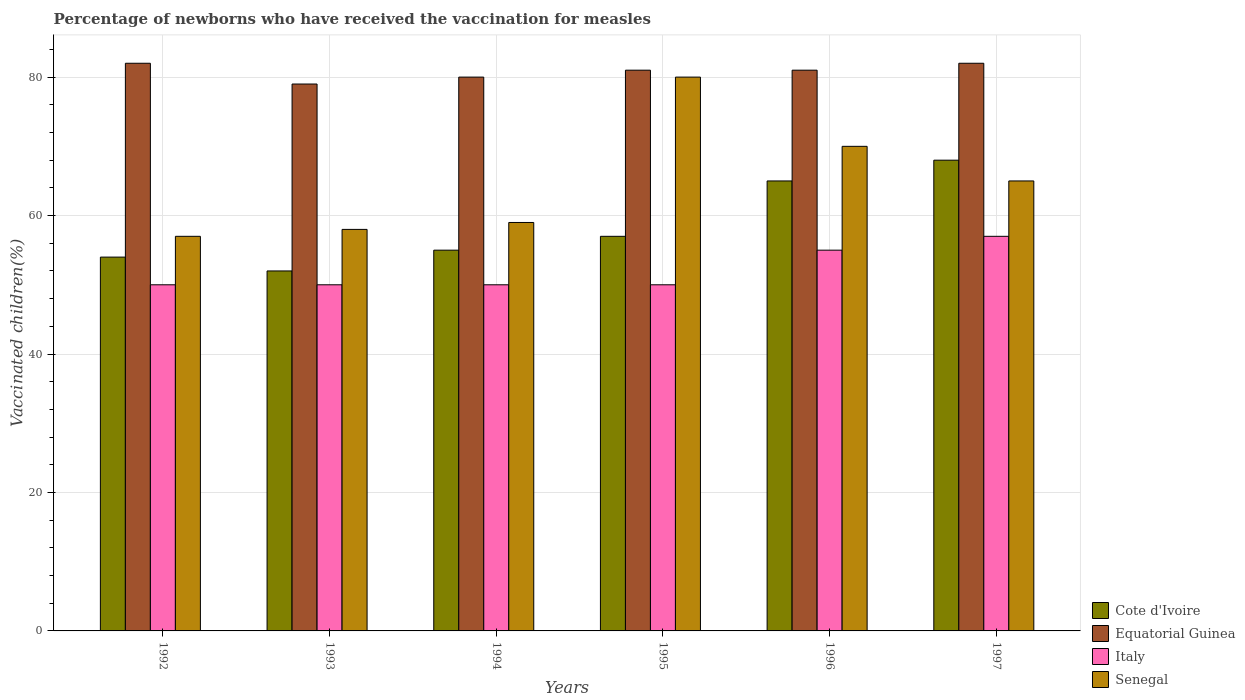How many different coloured bars are there?
Give a very brief answer. 4. How many groups of bars are there?
Your response must be concise. 6. How many bars are there on the 2nd tick from the left?
Provide a short and direct response. 4. What is the percentage of vaccinated children in Cote d'Ivoire in 1992?
Your answer should be compact. 54. Across all years, what is the maximum percentage of vaccinated children in Italy?
Offer a terse response. 57. What is the total percentage of vaccinated children in Italy in the graph?
Provide a short and direct response. 312. What is the average percentage of vaccinated children in Senegal per year?
Your response must be concise. 64.83. In the year 1992, what is the difference between the percentage of vaccinated children in Senegal and percentage of vaccinated children in Cote d'Ivoire?
Keep it short and to the point. 3. Is the difference between the percentage of vaccinated children in Senegal in 1993 and 1994 greater than the difference between the percentage of vaccinated children in Cote d'Ivoire in 1993 and 1994?
Your answer should be compact. Yes. What is the difference between the highest and the lowest percentage of vaccinated children in Italy?
Offer a terse response. 7. Is it the case that in every year, the sum of the percentage of vaccinated children in Senegal and percentage of vaccinated children in Equatorial Guinea is greater than the sum of percentage of vaccinated children in Cote d'Ivoire and percentage of vaccinated children in Italy?
Provide a succinct answer. Yes. What does the 2nd bar from the left in 1996 represents?
Keep it short and to the point. Equatorial Guinea. What does the 1st bar from the right in 1992 represents?
Offer a terse response. Senegal. Are the values on the major ticks of Y-axis written in scientific E-notation?
Offer a very short reply. No. Does the graph contain any zero values?
Provide a succinct answer. No. Does the graph contain grids?
Ensure brevity in your answer.  Yes. Where does the legend appear in the graph?
Offer a terse response. Bottom right. What is the title of the graph?
Make the answer very short. Percentage of newborns who have received the vaccination for measles. What is the label or title of the Y-axis?
Provide a short and direct response. Vaccinated children(%). What is the Vaccinated children(%) of Equatorial Guinea in 1992?
Offer a terse response. 82. What is the Vaccinated children(%) of Equatorial Guinea in 1993?
Your response must be concise. 79. What is the Vaccinated children(%) of Italy in 1993?
Keep it short and to the point. 50. What is the Vaccinated children(%) of Senegal in 1993?
Offer a very short reply. 58. What is the Vaccinated children(%) of Equatorial Guinea in 1994?
Your response must be concise. 80. What is the Vaccinated children(%) of Italy in 1994?
Offer a very short reply. 50. What is the Vaccinated children(%) of Equatorial Guinea in 1995?
Your answer should be very brief. 81. What is the Vaccinated children(%) of Italy in 1995?
Offer a very short reply. 50. What is the Vaccinated children(%) of Senegal in 1995?
Offer a terse response. 80. What is the Vaccinated children(%) in Cote d'Ivoire in 1996?
Your answer should be very brief. 65. What is the Vaccinated children(%) in Cote d'Ivoire in 1997?
Make the answer very short. 68. What is the Vaccinated children(%) of Equatorial Guinea in 1997?
Your response must be concise. 82. Across all years, what is the maximum Vaccinated children(%) in Cote d'Ivoire?
Offer a terse response. 68. Across all years, what is the maximum Vaccinated children(%) in Equatorial Guinea?
Provide a succinct answer. 82. Across all years, what is the maximum Vaccinated children(%) in Italy?
Give a very brief answer. 57. Across all years, what is the minimum Vaccinated children(%) in Cote d'Ivoire?
Keep it short and to the point. 52. Across all years, what is the minimum Vaccinated children(%) in Equatorial Guinea?
Ensure brevity in your answer.  79. Across all years, what is the minimum Vaccinated children(%) in Senegal?
Keep it short and to the point. 57. What is the total Vaccinated children(%) of Cote d'Ivoire in the graph?
Provide a succinct answer. 351. What is the total Vaccinated children(%) in Equatorial Guinea in the graph?
Your response must be concise. 485. What is the total Vaccinated children(%) in Italy in the graph?
Give a very brief answer. 312. What is the total Vaccinated children(%) of Senegal in the graph?
Ensure brevity in your answer.  389. What is the difference between the Vaccinated children(%) in Cote d'Ivoire in 1992 and that in 1993?
Make the answer very short. 2. What is the difference between the Vaccinated children(%) in Italy in 1992 and that in 1993?
Ensure brevity in your answer.  0. What is the difference between the Vaccinated children(%) of Senegal in 1992 and that in 1993?
Your answer should be compact. -1. What is the difference between the Vaccinated children(%) in Cote d'Ivoire in 1992 and that in 1995?
Offer a very short reply. -3. What is the difference between the Vaccinated children(%) of Italy in 1992 and that in 1995?
Ensure brevity in your answer.  0. What is the difference between the Vaccinated children(%) in Equatorial Guinea in 1992 and that in 1996?
Ensure brevity in your answer.  1. What is the difference between the Vaccinated children(%) of Italy in 1992 and that in 1996?
Offer a very short reply. -5. What is the difference between the Vaccinated children(%) in Senegal in 1992 and that in 1996?
Your response must be concise. -13. What is the difference between the Vaccinated children(%) of Cote d'Ivoire in 1992 and that in 1997?
Ensure brevity in your answer.  -14. What is the difference between the Vaccinated children(%) in Equatorial Guinea in 1993 and that in 1994?
Your answer should be very brief. -1. What is the difference between the Vaccinated children(%) of Cote d'Ivoire in 1993 and that in 1995?
Offer a very short reply. -5. What is the difference between the Vaccinated children(%) of Equatorial Guinea in 1993 and that in 1995?
Your answer should be very brief. -2. What is the difference between the Vaccinated children(%) in Senegal in 1993 and that in 1995?
Your answer should be very brief. -22. What is the difference between the Vaccinated children(%) of Equatorial Guinea in 1993 and that in 1996?
Ensure brevity in your answer.  -2. What is the difference between the Vaccinated children(%) in Italy in 1993 and that in 1996?
Give a very brief answer. -5. What is the difference between the Vaccinated children(%) in Cote d'Ivoire in 1993 and that in 1997?
Offer a very short reply. -16. What is the difference between the Vaccinated children(%) of Equatorial Guinea in 1993 and that in 1997?
Make the answer very short. -3. What is the difference between the Vaccinated children(%) of Italy in 1993 and that in 1997?
Give a very brief answer. -7. What is the difference between the Vaccinated children(%) of Cote d'Ivoire in 1994 and that in 1995?
Your answer should be very brief. -2. What is the difference between the Vaccinated children(%) of Equatorial Guinea in 1994 and that in 1995?
Your response must be concise. -1. What is the difference between the Vaccinated children(%) in Italy in 1994 and that in 1996?
Your response must be concise. -5. What is the difference between the Vaccinated children(%) in Senegal in 1994 and that in 1996?
Ensure brevity in your answer.  -11. What is the difference between the Vaccinated children(%) of Equatorial Guinea in 1994 and that in 1997?
Make the answer very short. -2. What is the difference between the Vaccinated children(%) of Italy in 1994 and that in 1997?
Provide a succinct answer. -7. What is the difference between the Vaccinated children(%) of Senegal in 1994 and that in 1997?
Provide a short and direct response. -6. What is the difference between the Vaccinated children(%) of Cote d'Ivoire in 1995 and that in 1996?
Offer a very short reply. -8. What is the difference between the Vaccinated children(%) of Equatorial Guinea in 1995 and that in 1996?
Give a very brief answer. 0. What is the difference between the Vaccinated children(%) in Italy in 1995 and that in 1996?
Your answer should be very brief. -5. What is the difference between the Vaccinated children(%) of Senegal in 1995 and that in 1996?
Offer a terse response. 10. What is the difference between the Vaccinated children(%) in Cote d'Ivoire in 1995 and that in 1997?
Ensure brevity in your answer.  -11. What is the difference between the Vaccinated children(%) of Equatorial Guinea in 1995 and that in 1997?
Make the answer very short. -1. What is the difference between the Vaccinated children(%) of Italy in 1996 and that in 1997?
Offer a very short reply. -2. What is the difference between the Vaccinated children(%) in Senegal in 1996 and that in 1997?
Give a very brief answer. 5. What is the difference between the Vaccinated children(%) in Cote d'Ivoire in 1992 and the Vaccinated children(%) in Italy in 1993?
Offer a very short reply. 4. What is the difference between the Vaccinated children(%) in Equatorial Guinea in 1992 and the Vaccinated children(%) in Italy in 1993?
Make the answer very short. 32. What is the difference between the Vaccinated children(%) of Equatorial Guinea in 1992 and the Vaccinated children(%) of Senegal in 1993?
Provide a short and direct response. 24. What is the difference between the Vaccinated children(%) of Cote d'Ivoire in 1992 and the Vaccinated children(%) of Equatorial Guinea in 1994?
Provide a short and direct response. -26. What is the difference between the Vaccinated children(%) of Cote d'Ivoire in 1992 and the Vaccinated children(%) of Senegal in 1994?
Provide a succinct answer. -5. What is the difference between the Vaccinated children(%) of Equatorial Guinea in 1992 and the Vaccinated children(%) of Italy in 1994?
Offer a very short reply. 32. What is the difference between the Vaccinated children(%) of Equatorial Guinea in 1992 and the Vaccinated children(%) of Senegal in 1994?
Provide a succinct answer. 23. What is the difference between the Vaccinated children(%) of Italy in 1992 and the Vaccinated children(%) of Senegal in 1994?
Your answer should be very brief. -9. What is the difference between the Vaccinated children(%) in Cote d'Ivoire in 1992 and the Vaccinated children(%) in Italy in 1995?
Keep it short and to the point. 4. What is the difference between the Vaccinated children(%) of Italy in 1992 and the Vaccinated children(%) of Senegal in 1995?
Offer a terse response. -30. What is the difference between the Vaccinated children(%) of Cote d'Ivoire in 1992 and the Vaccinated children(%) of Italy in 1996?
Ensure brevity in your answer.  -1. What is the difference between the Vaccinated children(%) in Cote d'Ivoire in 1992 and the Vaccinated children(%) in Senegal in 1996?
Ensure brevity in your answer.  -16. What is the difference between the Vaccinated children(%) in Equatorial Guinea in 1992 and the Vaccinated children(%) in Italy in 1996?
Provide a short and direct response. 27. What is the difference between the Vaccinated children(%) in Equatorial Guinea in 1992 and the Vaccinated children(%) in Italy in 1997?
Ensure brevity in your answer.  25. What is the difference between the Vaccinated children(%) of Cote d'Ivoire in 1993 and the Vaccinated children(%) of Equatorial Guinea in 1994?
Give a very brief answer. -28. What is the difference between the Vaccinated children(%) in Cote d'Ivoire in 1993 and the Vaccinated children(%) in Italy in 1994?
Provide a short and direct response. 2. What is the difference between the Vaccinated children(%) of Cote d'Ivoire in 1993 and the Vaccinated children(%) of Senegal in 1994?
Your answer should be compact. -7. What is the difference between the Vaccinated children(%) in Equatorial Guinea in 1993 and the Vaccinated children(%) in Italy in 1994?
Offer a very short reply. 29. What is the difference between the Vaccinated children(%) of Cote d'Ivoire in 1993 and the Vaccinated children(%) of Equatorial Guinea in 1995?
Offer a very short reply. -29. What is the difference between the Vaccinated children(%) of Equatorial Guinea in 1993 and the Vaccinated children(%) of Italy in 1995?
Provide a succinct answer. 29. What is the difference between the Vaccinated children(%) in Italy in 1993 and the Vaccinated children(%) in Senegal in 1995?
Your answer should be compact. -30. What is the difference between the Vaccinated children(%) of Cote d'Ivoire in 1993 and the Vaccinated children(%) of Equatorial Guinea in 1996?
Your answer should be very brief. -29. What is the difference between the Vaccinated children(%) in Cote d'Ivoire in 1993 and the Vaccinated children(%) in Italy in 1996?
Give a very brief answer. -3. What is the difference between the Vaccinated children(%) in Equatorial Guinea in 1993 and the Vaccinated children(%) in Italy in 1996?
Offer a terse response. 24. What is the difference between the Vaccinated children(%) of Cote d'Ivoire in 1993 and the Vaccinated children(%) of Senegal in 1997?
Provide a short and direct response. -13. What is the difference between the Vaccinated children(%) of Equatorial Guinea in 1993 and the Vaccinated children(%) of Italy in 1997?
Your answer should be compact. 22. What is the difference between the Vaccinated children(%) of Italy in 1993 and the Vaccinated children(%) of Senegal in 1997?
Make the answer very short. -15. What is the difference between the Vaccinated children(%) in Cote d'Ivoire in 1994 and the Vaccinated children(%) in Senegal in 1995?
Ensure brevity in your answer.  -25. What is the difference between the Vaccinated children(%) of Italy in 1994 and the Vaccinated children(%) of Senegal in 1995?
Make the answer very short. -30. What is the difference between the Vaccinated children(%) of Cote d'Ivoire in 1994 and the Vaccinated children(%) of Equatorial Guinea in 1997?
Provide a succinct answer. -27. What is the difference between the Vaccinated children(%) of Equatorial Guinea in 1994 and the Vaccinated children(%) of Italy in 1997?
Give a very brief answer. 23. What is the difference between the Vaccinated children(%) in Italy in 1994 and the Vaccinated children(%) in Senegal in 1997?
Ensure brevity in your answer.  -15. What is the difference between the Vaccinated children(%) of Cote d'Ivoire in 1995 and the Vaccinated children(%) of Italy in 1996?
Make the answer very short. 2. What is the difference between the Vaccinated children(%) of Cote d'Ivoire in 1995 and the Vaccinated children(%) of Senegal in 1996?
Offer a terse response. -13. What is the difference between the Vaccinated children(%) in Cote d'Ivoire in 1995 and the Vaccinated children(%) in Equatorial Guinea in 1997?
Your answer should be very brief. -25. What is the difference between the Vaccinated children(%) in Equatorial Guinea in 1995 and the Vaccinated children(%) in Senegal in 1997?
Keep it short and to the point. 16. What is the difference between the Vaccinated children(%) of Italy in 1995 and the Vaccinated children(%) of Senegal in 1997?
Provide a succinct answer. -15. What is the difference between the Vaccinated children(%) of Cote d'Ivoire in 1996 and the Vaccinated children(%) of Equatorial Guinea in 1997?
Give a very brief answer. -17. What is the difference between the Vaccinated children(%) of Cote d'Ivoire in 1996 and the Vaccinated children(%) of Italy in 1997?
Give a very brief answer. 8. What is the difference between the Vaccinated children(%) of Equatorial Guinea in 1996 and the Vaccinated children(%) of Italy in 1997?
Provide a short and direct response. 24. What is the difference between the Vaccinated children(%) of Equatorial Guinea in 1996 and the Vaccinated children(%) of Senegal in 1997?
Your response must be concise. 16. What is the average Vaccinated children(%) in Cote d'Ivoire per year?
Keep it short and to the point. 58.5. What is the average Vaccinated children(%) of Equatorial Guinea per year?
Your response must be concise. 80.83. What is the average Vaccinated children(%) of Italy per year?
Offer a very short reply. 52. What is the average Vaccinated children(%) in Senegal per year?
Your response must be concise. 64.83. In the year 1992, what is the difference between the Vaccinated children(%) in Cote d'Ivoire and Vaccinated children(%) in Italy?
Offer a very short reply. 4. In the year 1992, what is the difference between the Vaccinated children(%) of Equatorial Guinea and Vaccinated children(%) of Senegal?
Offer a very short reply. 25. In the year 1993, what is the difference between the Vaccinated children(%) of Cote d'Ivoire and Vaccinated children(%) of Equatorial Guinea?
Your answer should be very brief. -27. In the year 1993, what is the difference between the Vaccinated children(%) of Cote d'Ivoire and Vaccinated children(%) of Italy?
Ensure brevity in your answer.  2. In the year 1993, what is the difference between the Vaccinated children(%) in Equatorial Guinea and Vaccinated children(%) in Senegal?
Provide a short and direct response. 21. In the year 1993, what is the difference between the Vaccinated children(%) in Italy and Vaccinated children(%) in Senegal?
Offer a terse response. -8. In the year 1994, what is the difference between the Vaccinated children(%) of Equatorial Guinea and Vaccinated children(%) of Italy?
Keep it short and to the point. 30. In the year 1994, what is the difference between the Vaccinated children(%) of Equatorial Guinea and Vaccinated children(%) of Senegal?
Your answer should be very brief. 21. In the year 1995, what is the difference between the Vaccinated children(%) of Cote d'Ivoire and Vaccinated children(%) of Senegal?
Provide a short and direct response. -23. In the year 1995, what is the difference between the Vaccinated children(%) of Italy and Vaccinated children(%) of Senegal?
Keep it short and to the point. -30. In the year 1996, what is the difference between the Vaccinated children(%) of Italy and Vaccinated children(%) of Senegal?
Provide a short and direct response. -15. In the year 1997, what is the difference between the Vaccinated children(%) of Cote d'Ivoire and Vaccinated children(%) of Equatorial Guinea?
Your answer should be very brief. -14. In the year 1997, what is the difference between the Vaccinated children(%) in Cote d'Ivoire and Vaccinated children(%) in Italy?
Offer a terse response. 11. In the year 1997, what is the difference between the Vaccinated children(%) in Cote d'Ivoire and Vaccinated children(%) in Senegal?
Provide a succinct answer. 3. In the year 1997, what is the difference between the Vaccinated children(%) of Equatorial Guinea and Vaccinated children(%) of Italy?
Keep it short and to the point. 25. In the year 1997, what is the difference between the Vaccinated children(%) in Equatorial Guinea and Vaccinated children(%) in Senegal?
Keep it short and to the point. 17. In the year 1997, what is the difference between the Vaccinated children(%) in Italy and Vaccinated children(%) in Senegal?
Offer a very short reply. -8. What is the ratio of the Vaccinated children(%) of Cote d'Ivoire in 1992 to that in 1993?
Provide a succinct answer. 1.04. What is the ratio of the Vaccinated children(%) of Equatorial Guinea in 1992 to that in 1993?
Ensure brevity in your answer.  1.04. What is the ratio of the Vaccinated children(%) in Italy in 1992 to that in 1993?
Provide a succinct answer. 1. What is the ratio of the Vaccinated children(%) of Senegal in 1992 to that in 1993?
Your response must be concise. 0.98. What is the ratio of the Vaccinated children(%) of Cote d'Ivoire in 1992 to that in 1994?
Give a very brief answer. 0.98. What is the ratio of the Vaccinated children(%) in Italy in 1992 to that in 1994?
Make the answer very short. 1. What is the ratio of the Vaccinated children(%) in Senegal in 1992 to that in 1994?
Provide a short and direct response. 0.97. What is the ratio of the Vaccinated children(%) in Equatorial Guinea in 1992 to that in 1995?
Offer a very short reply. 1.01. What is the ratio of the Vaccinated children(%) of Senegal in 1992 to that in 1995?
Your answer should be very brief. 0.71. What is the ratio of the Vaccinated children(%) of Cote d'Ivoire in 1992 to that in 1996?
Your answer should be very brief. 0.83. What is the ratio of the Vaccinated children(%) in Equatorial Guinea in 1992 to that in 1996?
Provide a succinct answer. 1.01. What is the ratio of the Vaccinated children(%) of Italy in 1992 to that in 1996?
Offer a terse response. 0.91. What is the ratio of the Vaccinated children(%) of Senegal in 1992 to that in 1996?
Provide a short and direct response. 0.81. What is the ratio of the Vaccinated children(%) in Cote d'Ivoire in 1992 to that in 1997?
Keep it short and to the point. 0.79. What is the ratio of the Vaccinated children(%) in Italy in 1992 to that in 1997?
Your answer should be compact. 0.88. What is the ratio of the Vaccinated children(%) in Senegal in 1992 to that in 1997?
Provide a short and direct response. 0.88. What is the ratio of the Vaccinated children(%) in Cote d'Ivoire in 1993 to that in 1994?
Ensure brevity in your answer.  0.95. What is the ratio of the Vaccinated children(%) of Equatorial Guinea in 1993 to that in 1994?
Keep it short and to the point. 0.99. What is the ratio of the Vaccinated children(%) of Senegal in 1993 to that in 1994?
Your answer should be very brief. 0.98. What is the ratio of the Vaccinated children(%) of Cote d'Ivoire in 1993 to that in 1995?
Provide a short and direct response. 0.91. What is the ratio of the Vaccinated children(%) of Equatorial Guinea in 1993 to that in 1995?
Give a very brief answer. 0.98. What is the ratio of the Vaccinated children(%) in Italy in 1993 to that in 1995?
Make the answer very short. 1. What is the ratio of the Vaccinated children(%) in Senegal in 1993 to that in 1995?
Your answer should be very brief. 0.72. What is the ratio of the Vaccinated children(%) in Cote d'Ivoire in 1993 to that in 1996?
Your answer should be very brief. 0.8. What is the ratio of the Vaccinated children(%) of Equatorial Guinea in 1993 to that in 1996?
Offer a terse response. 0.98. What is the ratio of the Vaccinated children(%) of Senegal in 1993 to that in 1996?
Offer a very short reply. 0.83. What is the ratio of the Vaccinated children(%) in Cote d'Ivoire in 1993 to that in 1997?
Provide a short and direct response. 0.76. What is the ratio of the Vaccinated children(%) of Equatorial Guinea in 1993 to that in 1997?
Provide a succinct answer. 0.96. What is the ratio of the Vaccinated children(%) in Italy in 1993 to that in 1997?
Your response must be concise. 0.88. What is the ratio of the Vaccinated children(%) in Senegal in 1993 to that in 1997?
Give a very brief answer. 0.89. What is the ratio of the Vaccinated children(%) of Cote d'Ivoire in 1994 to that in 1995?
Offer a terse response. 0.96. What is the ratio of the Vaccinated children(%) of Italy in 1994 to that in 1995?
Your answer should be very brief. 1. What is the ratio of the Vaccinated children(%) of Senegal in 1994 to that in 1995?
Your response must be concise. 0.74. What is the ratio of the Vaccinated children(%) of Cote d'Ivoire in 1994 to that in 1996?
Your answer should be compact. 0.85. What is the ratio of the Vaccinated children(%) of Equatorial Guinea in 1994 to that in 1996?
Offer a very short reply. 0.99. What is the ratio of the Vaccinated children(%) of Senegal in 1994 to that in 1996?
Provide a short and direct response. 0.84. What is the ratio of the Vaccinated children(%) in Cote d'Ivoire in 1994 to that in 1997?
Your answer should be very brief. 0.81. What is the ratio of the Vaccinated children(%) of Equatorial Guinea in 1994 to that in 1997?
Your response must be concise. 0.98. What is the ratio of the Vaccinated children(%) in Italy in 1994 to that in 1997?
Offer a very short reply. 0.88. What is the ratio of the Vaccinated children(%) of Senegal in 1994 to that in 1997?
Offer a very short reply. 0.91. What is the ratio of the Vaccinated children(%) in Cote d'Ivoire in 1995 to that in 1996?
Make the answer very short. 0.88. What is the ratio of the Vaccinated children(%) in Italy in 1995 to that in 1996?
Offer a very short reply. 0.91. What is the ratio of the Vaccinated children(%) of Senegal in 1995 to that in 1996?
Your response must be concise. 1.14. What is the ratio of the Vaccinated children(%) in Cote d'Ivoire in 1995 to that in 1997?
Provide a short and direct response. 0.84. What is the ratio of the Vaccinated children(%) of Equatorial Guinea in 1995 to that in 1997?
Give a very brief answer. 0.99. What is the ratio of the Vaccinated children(%) of Italy in 1995 to that in 1997?
Your answer should be very brief. 0.88. What is the ratio of the Vaccinated children(%) of Senegal in 1995 to that in 1997?
Your answer should be compact. 1.23. What is the ratio of the Vaccinated children(%) of Cote d'Ivoire in 1996 to that in 1997?
Your answer should be very brief. 0.96. What is the ratio of the Vaccinated children(%) of Italy in 1996 to that in 1997?
Offer a very short reply. 0.96. What is the difference between the highest and the second highest Vaccinated children(%) of Cote d'Ivoire?
Offer a very short reply. 3. What is the difference between the highest and the lowest Vaccinated children(%) of Cote d'Ivoire?
Make the answer very short. 16. What is the difference between the highest and the lowest Vaccinated children(%) of Equatorial Guinea?
Your answer should be compact. 3. What is the difference between the highest and the lowest Vaccinated children(%) of Italy?
Provide a succinct answer. 7. 